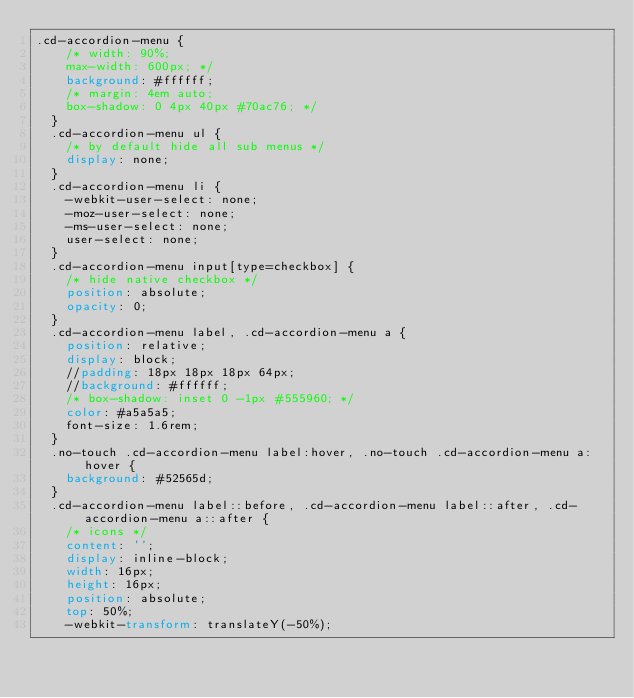Convert code to text. <code><loc_0><loc_0><loc_500><loc_500><_CSS_>.cd-accordion-menu {
    /* width: 90%;
    max-width: 600px; */
    background: #ffffff;
    /* margin: 4em auto;
    box-shadow: 0 4px 40px #70ac76; */
  }
  .cd-accordion-menu ul {
    /* by default hide all sub menus */
    display: none;
  }
  .cd-accordion-menu li {
    -webkit-user-select: none;
    -moz-user-select: none;
    -ms-user-select: none;
    user-select: none;
  }
  .cd-accordion-menu input[type=checkbox] {
    /* hide native checkbox */
    position: absolute;
    opacity: 0;
  }
  .cd-accordion-menu label, .cd-accordion-menu a {
    position: relative;
    display: block;
    //padding: 18px 18px 18px 64px;
    //background: #ffffff;
    /* box-shadow: inset 0 -1px #555960; */
    color: #a5a5a5;
    font-size: 1.6rem;
  }
  .no-touch .cd-accordion-menu label:hover, .no-touch .cd-accordion-menu a:hover {
    background: #52565d;
  }
  .cd-accordion-menu label::before, .cd-accordion-menu label::after, .cd-accordion-menu a::after {
    /* icons */
    content: '';
    display: inline-block;
    width: 16px;
    height: 16px;
    position: absolute;
    top: 50%;
    -webkit-transform: translateY(-50%);</code> 